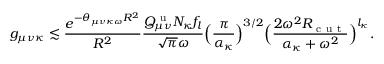Convert formula to latex. <formula><loc_0><loc_0><loc_500><loc_500>g _ { \mu \nu \kappa } \lesssim \frac { e ^ { - \theta _ { \mu \nu \kappa \omega } R ^ { 2 } } } { R ^ { 2 } } \frac { Q _ { \mu \nu } ^ { u } N _ { \kappa } f _ { l } } { \sqrt { \pi } \omega } \left ( \frac { \pi } { \alpha _ { \kappa } } \right ) ^ { 3 / 2 } \left ( \frac { 2 \omega ^ { 2 } R _ { c u t } } { \alpha _ { \kappa } + \omega ^ { 2 } } \right ) ^ { l _ { \kappa } } .</formula> 